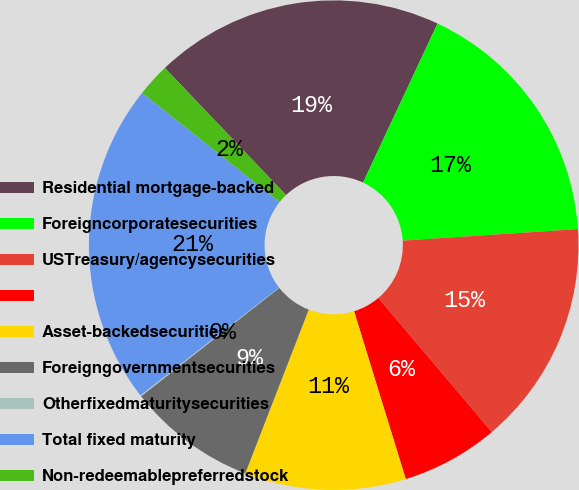<chart> <loc_0><loc_0><loc_500><loc_500><pie_chart><fcel>Residential mortgage-backed<fcel>Foreigncorporatesecurities<fcel>USTreasury/agencysecurities<fcel>Unnamed: 3<fcel>Asset-backedsecurities<fcel>Foreigngovernmentsecurities<fcel>Otherfixedmaturitysecurities<fcel>Total fixed maturity<fcel>Non-redeemablepreferredstock<nl><fcel>19.09%<fcel>16.98%<fcel>14.87%<fcel>6.42%<fcel>10.64%<fcel>8.53%<fcel>0.08%<fcel>21.2%<fcel>2.19%<nl></chart> 